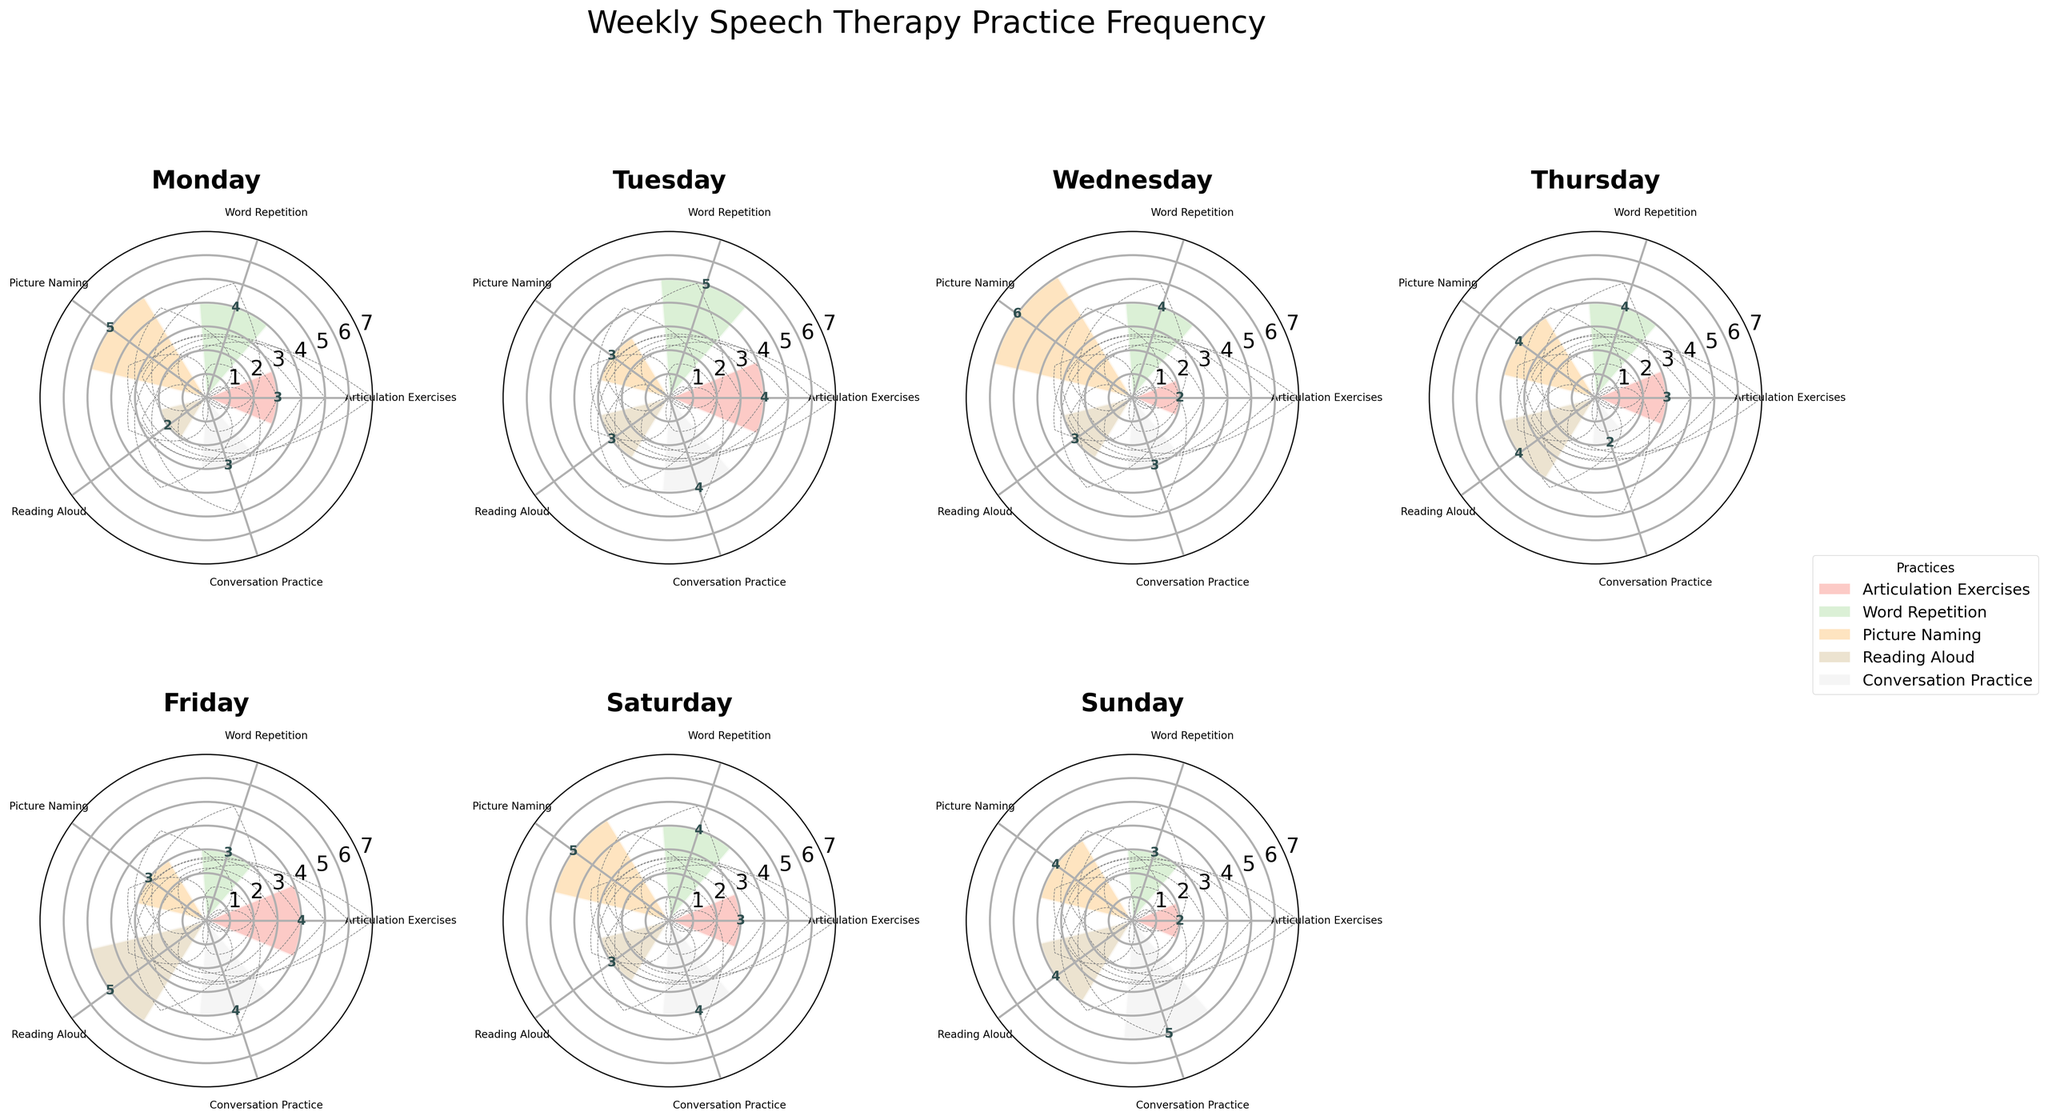What is the title of the figure? The title is located at the top of the figure and reads "Weekly Speech Therapy Practice Frequency".
Answer: Weekly Speech Therapy Practice Frequency How many types of speech therapy practices are illustrated in the figure? The figure has different colored bars for each type of practice. By counting the unique colors and checking the legend on the right, there are five types of practices.
Answer: Five Which day has the highest frequency of Picture Naming practice? By examining the radial bars in each subplot, Wednesday has the longest bar corresponding to Picture Naming with a frequency of 6.
Answer: Wednesday What is the average frequency of Articulation Exercises across the week? Add up the frequencies for Articulation Exercises: 3 (Mon) + 4 (Tue) + 2 (Wed) + 3 (Thu) + 4 (Fri) + 3 (Sat) + 2 (Sun) = 21. Then divide by 7 days: 21 / 7 = 3.
Answer: 3 Which practice has the most variation in frequency across different days? By comparing the lengths of the bars for each practice across the days, Reading Aloud has the widest range, from 2 on Monday to 5 on Friday.
Answer: Reading Aloud What is the combined frequency of Word Repetition and Picture Naming on Tuesday? From the Tuesday subplot, Word Repetition has a frequency of 5 and Picture Naming has 3. Adding them together: 5 + 3 = 8.
Answer: 8 On which day is the frequency of Conversation Practice the highest? The longest bar for Conversation Practice is on Sunday with a frequency of 5.
Answer: Sunday How does the frequency of Reading Aloud practice on Friday compare to that on Monday? The frequency on Friday is 5, while on Monday it is 2. Friday’s frequency is higher than Monday's.
Answer: Friday is higher What is the total frequency of all practices on Thursday? Add the frequencies for all practices on Thursday: 3 (Articulation Exercises) + 4 (Word Repetition) + 4 (Picture Naming) + 4 (Reading Aloud) + 2 (Conversation Practice) = 17.
Answer: 17 Which day has the lowest frequency of Conversation Practice? By comparing the lengths of the bars for Conversation Practice, Thursday has the shortest bar with a frequency of 2.
Answer: Thursday 